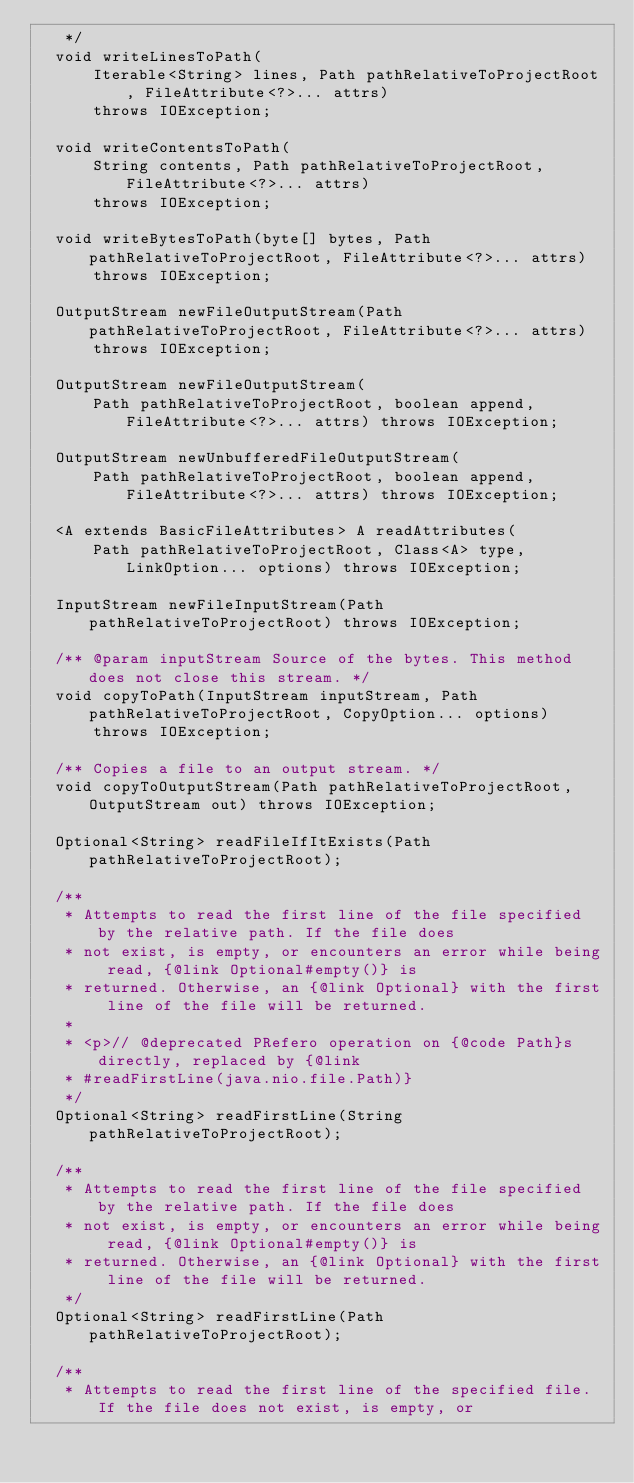Convert code to text. <code><loc_0><loc_0><loc_500><loc_500><_Java_>   */
  void writeLinesToPath(
      Iterable<String> lines, Path pathRelativeToProjectRoot, FileAttribute<?>... attrs)
      throws IOException;

  void writeContentsToPath(
      String contents, Path pathRelativeToProjectRoot, FileAttribute<?>... attrs)
      throws IOException;

  void writeBytesToPath(byte[] bytes, Path pathRelativeToProjectRoot, FileAttribute<?>... attrs)
      throws IOException;

  OutputStream newFileOutputStream(Path pathRelativeToProjectRoot, FileAttribute<?>... attrs)
      throws IOException;

  OutputStream newFileOutputStream(
      Path pathRelativeToProjectRoot, boolean append, FileAttribute<?>... attrs) throws IOException;

  OutputStream newUnbufferedFileOutputStream(
      Path pathRelativeToProjectRoot, boolean append, FileAttribute<?>... attrs) throws IOException;

  <A extends BasicFileAttributes> A readAttributes(
      Path pathRelativeToProjectRoot, Class<A> type, LinkOption... options) throws IOException;

  InputStream newFileInputStream(Path pathRelativeToProjectRoot) throws IOException;

  /** @param inputStream Source of the bytes. This method does not close this stream. */
  void copyToPath(InputStream inputStream, Path pathRelativeToProjectRoot, CopyOption... options)
      throws IOException;

  /** Copies a file to an output stream. */
  void copyToOutputStream(Path pathRelativeToProjectRoot, OutputStream out) throws IOException;

  Optional<String> readFileIfItExists(Path pathRelativeToProjectRoot);

  /**
   * Attempts to read the first line of the file specified by the relative path. If the file does
   * not exist, is empty, or encounters an error while being read, {@link Optional#empty()} is
   * returned. Otherwise, an {@link Optional} with the first line of the file will be returned.
   *
   * <p>// @deprecated PRefero operation on {@code Path}s directly, replaced by {@link
   * #readFirstLine(java.nio.file.Path)}
   */
  Optional<String> readFirstLine(String pathRelativeToProjectRoot);

  /**
   * Attempts to read the first line of the file specified by the relative path. If the file does
   * not exist, is empty, or encounters an error while being read, {@link Optional#empty()} is
   * returned. Otherwise, an {@link Optional} with the first line of the file will be returned.
   */
  Optional<String> readFirstLine(Path pathRelativeToProjectRoot);

  /**
   * Attempts to read the first line of the specified file. If the file does not exist, is empty, or</code> 